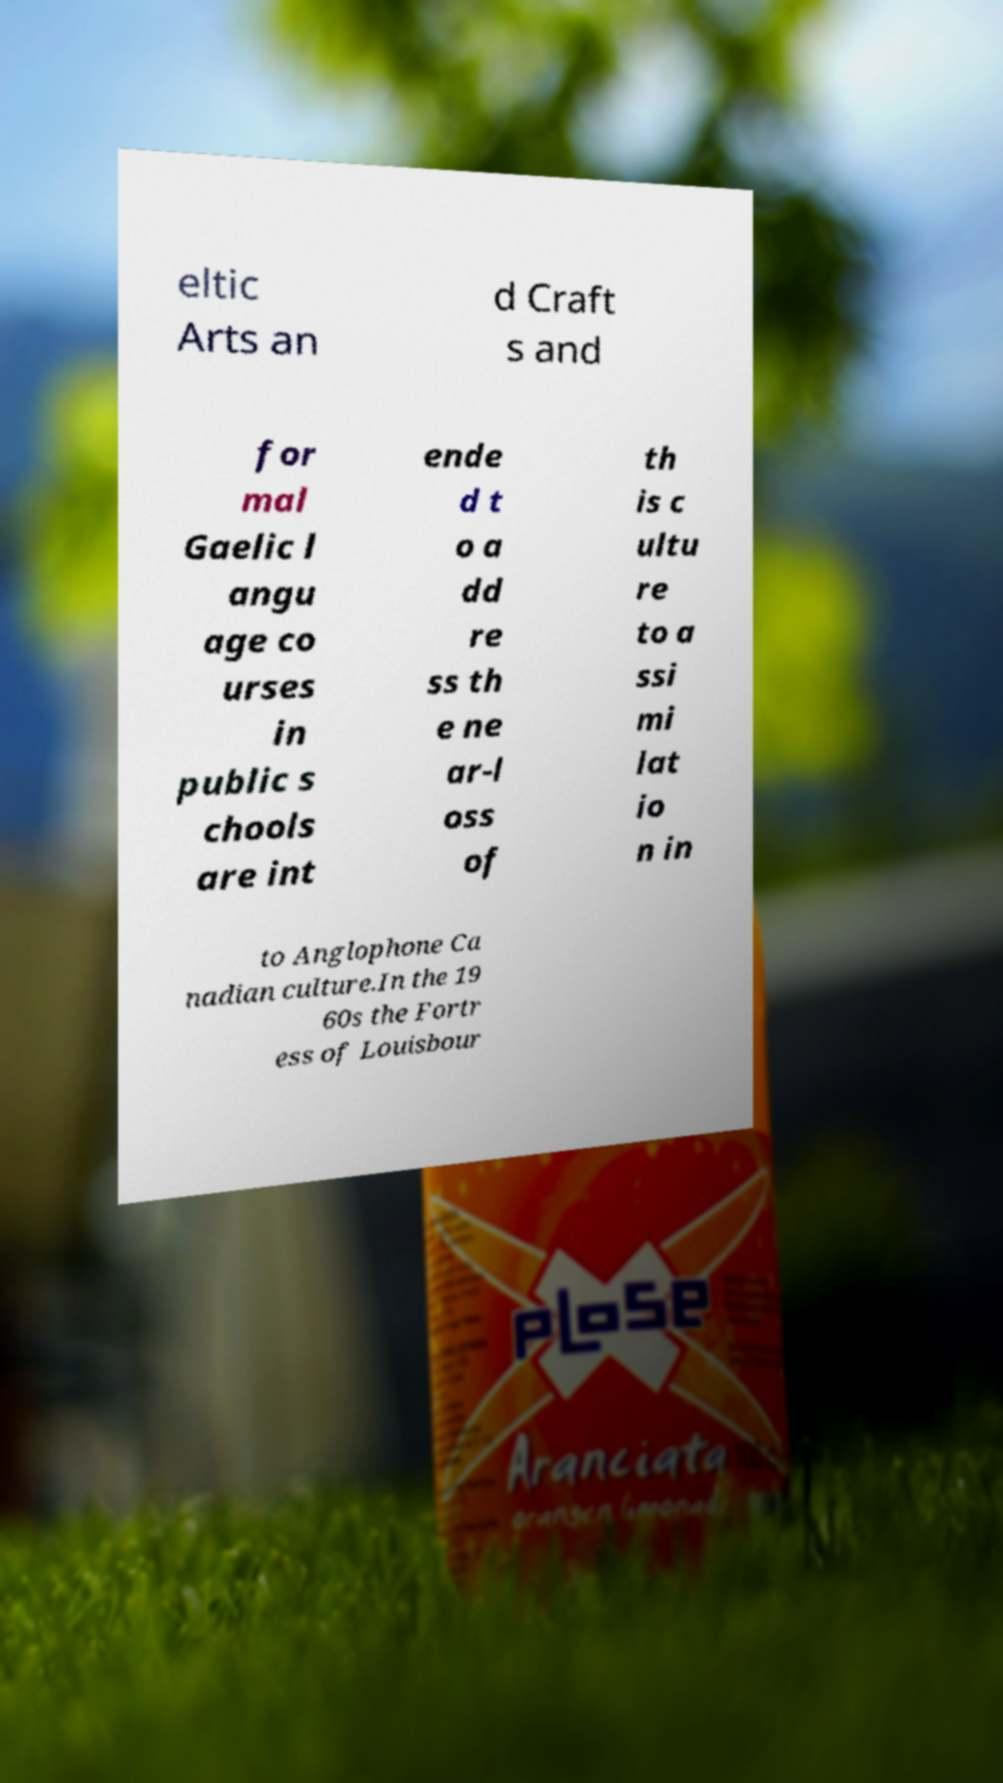Can you read and provide the text displayed in the image?This photo seems to have some interesting text. Can you extract and type it out for me? eltic Arts an d Craft s and for mal Gaelic l angu age co urses in public s chools are int ende d t o a dd re ss th e ne ar-l oss of th is c ultu re to a ssi mi lat io n in to Anglophone Ca nadian culture.In the 19 60s the Fortr ess of Louisbour 